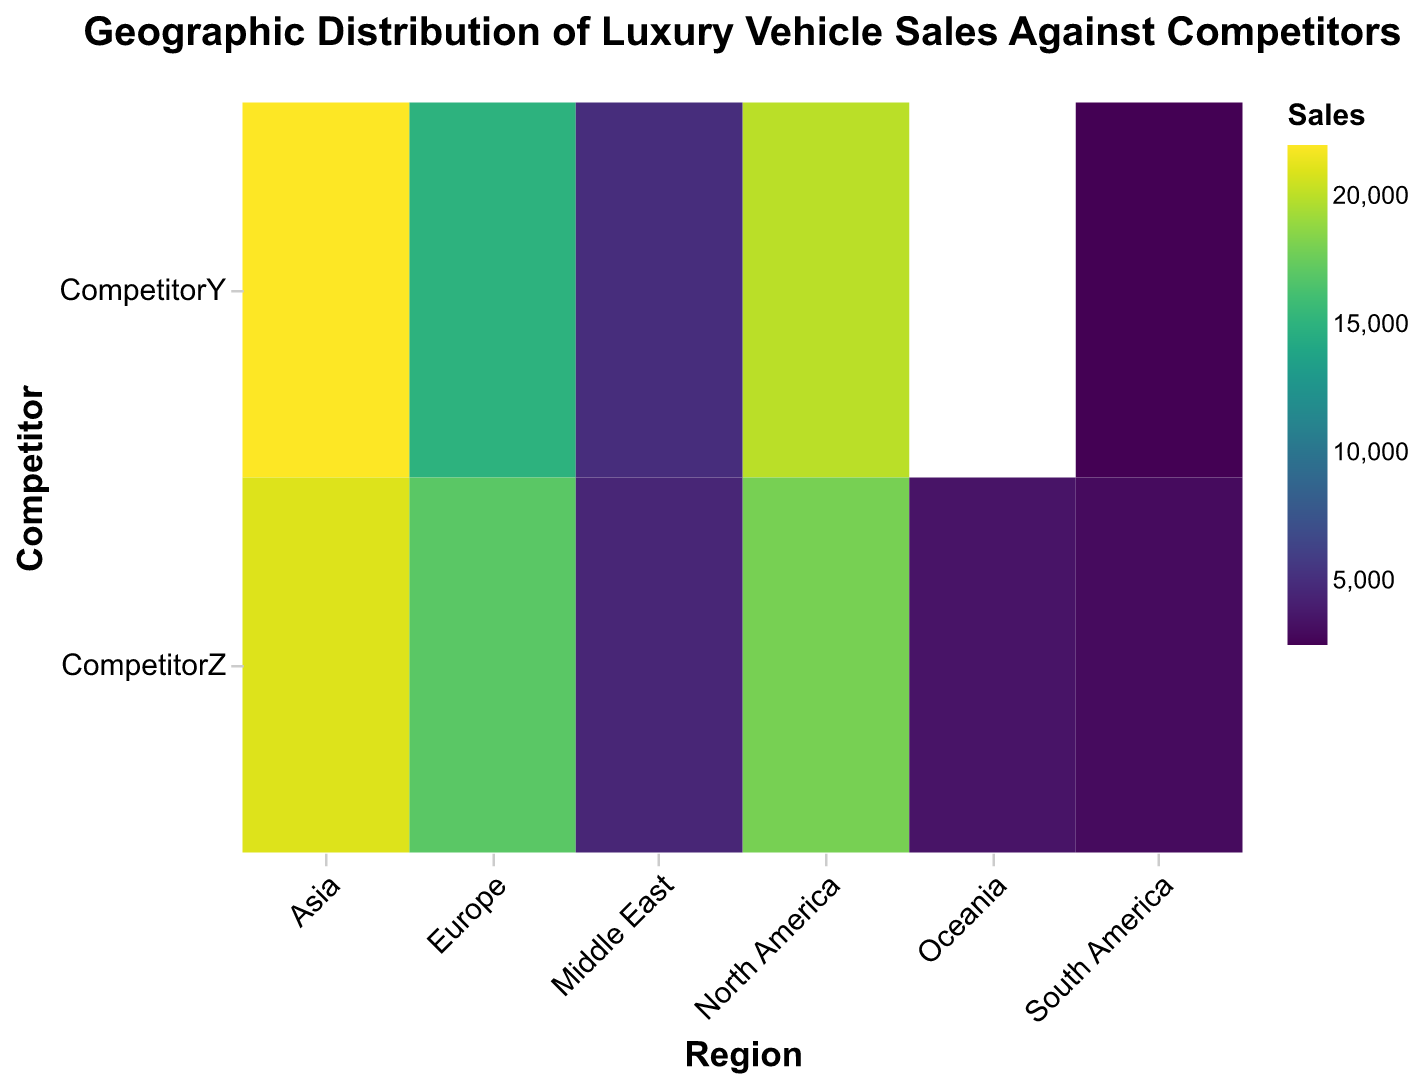What is the title of the heatmap? The title is displayed at the top of the heatmap in a larger, bold font. It provides a summary of the plot's content.
Answer: Geographic Distribution of Luxury Vehicle Sales Against Competitors Which region has the highest sales for BrandX against CompetitorY? Look at the cell colors under the "CompetitorY" row. The darkest color represents the highest sales, found in the "Asia" column.
Answer: Asia How do the sales in North America for BrandX compare between CompetitorY and CompetitorZ? Check the sales values for "North America" under both competitor columns. CompetitorY has a cell color denoting 20,000 sales, while CompetitorZ shows 18,000 sales.
Answer: CompetitorY has higher sales What is the total sales of BrandX in Europe for both competitors combined? Sum the sales values for "Europe" under both competitors: 15,000 (CompetitorY) + 17,000 (CompetitorZ) = 32,000.
Answer: 32,000 In which region does BrandX have the lowest sales against CompetitorY? Locate the lightest color cell in the "CompetitorY" row. This color represents the lowest sales, found in the "South America" column.
Answer: South America Which competitor has higher sales in Oceania? Compare the sales values for "Oceania" under both competitor columns. CompetitorY has 4,000 sales while CompetitorZ has 3,500.
Answer: CompetitorY Identify the regions where BrandX has better sales against both competitors. Compare the sales for both competitors per region. North America (20,000 vs 18,000), Asia (22,000 vs 21,000), South America (2,500 vs 3,000)—North America and Asia have higher sales for BrandX against both competitors.
Answer: North America, Asia What is the average sales of BrandX in Asia for both competitors? Calculate the average by summing the sales values for "Asia" under both competitors and dividing by 2: (22,000 + 21,000) / 2 = 21,500.
Answer: 21,500 Is BrandX's presence stronger in Europe or the Middle East based on total sales against all competitors? Sum the sales for all competitors in Europe (15,000 + 17,000 = 32,000) and the Middle East (5,000 + 4,500 = 9,500). Compare the sums: 32,000 (Europe) is greater than 9,500 (Middle East).
Answer: Europe What is the color scheme used to represent the sales data in the heatmap? The heatmap uses the "viridis" color scheme to represent sales quantities, ranging from lighter to darker shades as the sales values increase.
Answer: Viridis 